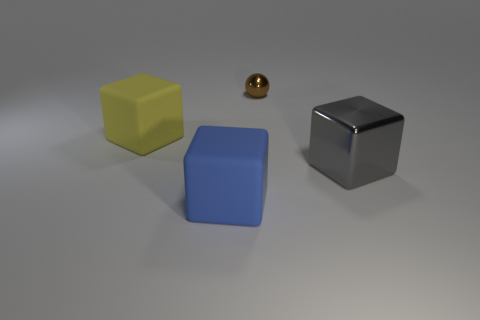Add 2 cyan matte cylinders. How many objects exist? 6 Subtract all cubes. How many objects are left? 1 Subtract all large cyan blocks. Subtract all shiny balls. How many objects are left? 3 Add 4 brown things. How many brown things are left? 5 Add 4 tiny purple metal balls. How many tiny purple metal balls exist? 4 Subtract 1 brown balls. How many objects are left? 3 